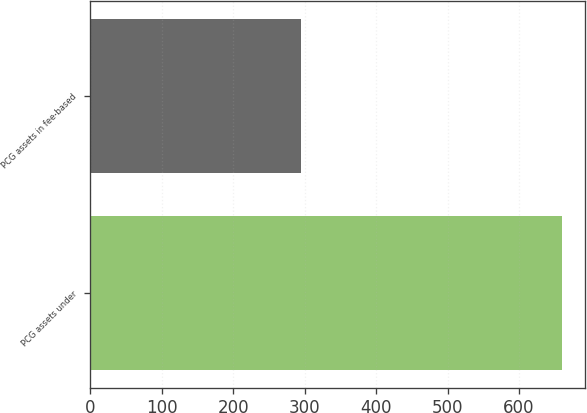Convert chart to OTSL. <chart><loc_0><loc_0><loc_500><loc_500><bar_chart><fcel>PCG assets under<fcel>PCG assets in fee-based<nl><fcel>659.5<fcel>294.5<nl></chart> 